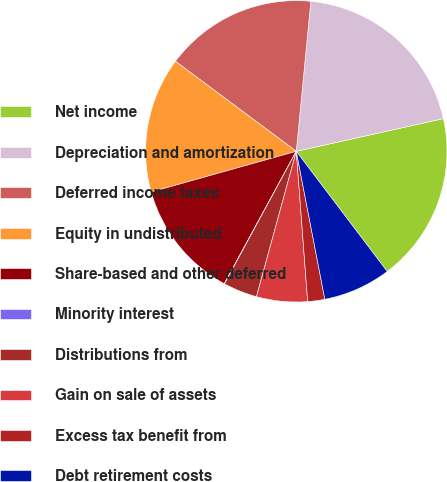Convert chart. <chart><loc_0><loc_0><loc_500><loc_500><pie_chart><fcel>Net income<fcel>Depreciation and amortization<fcel>Deferred income taxes<fcel>Equity in undistributed<fcel>Share-based and other deferred<fcel>Minority interest<fcel>Distributions from<fcel>Gain on sale of assets<fcel>Excess tax benefit from<fcel>Debt retirement costs<nl><fcel>18.17%<fcel>19.98%<fcel>16.35%<fcel>14.54%<fcel>12.72%<fcel>0.02%<fcel>3.65%<fcel>5.46%<fcel>1.83%<fcel>7.28%<nl></chart> 